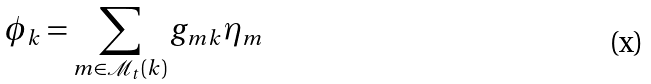<formula> <loc_0><loc_0><loc_500><loc_500>\phi _ { k } = \sum _ { m \in \mathcal { M } _ { t } ( k ) } g _ { m k } \eta _ { m } \,</formula> 